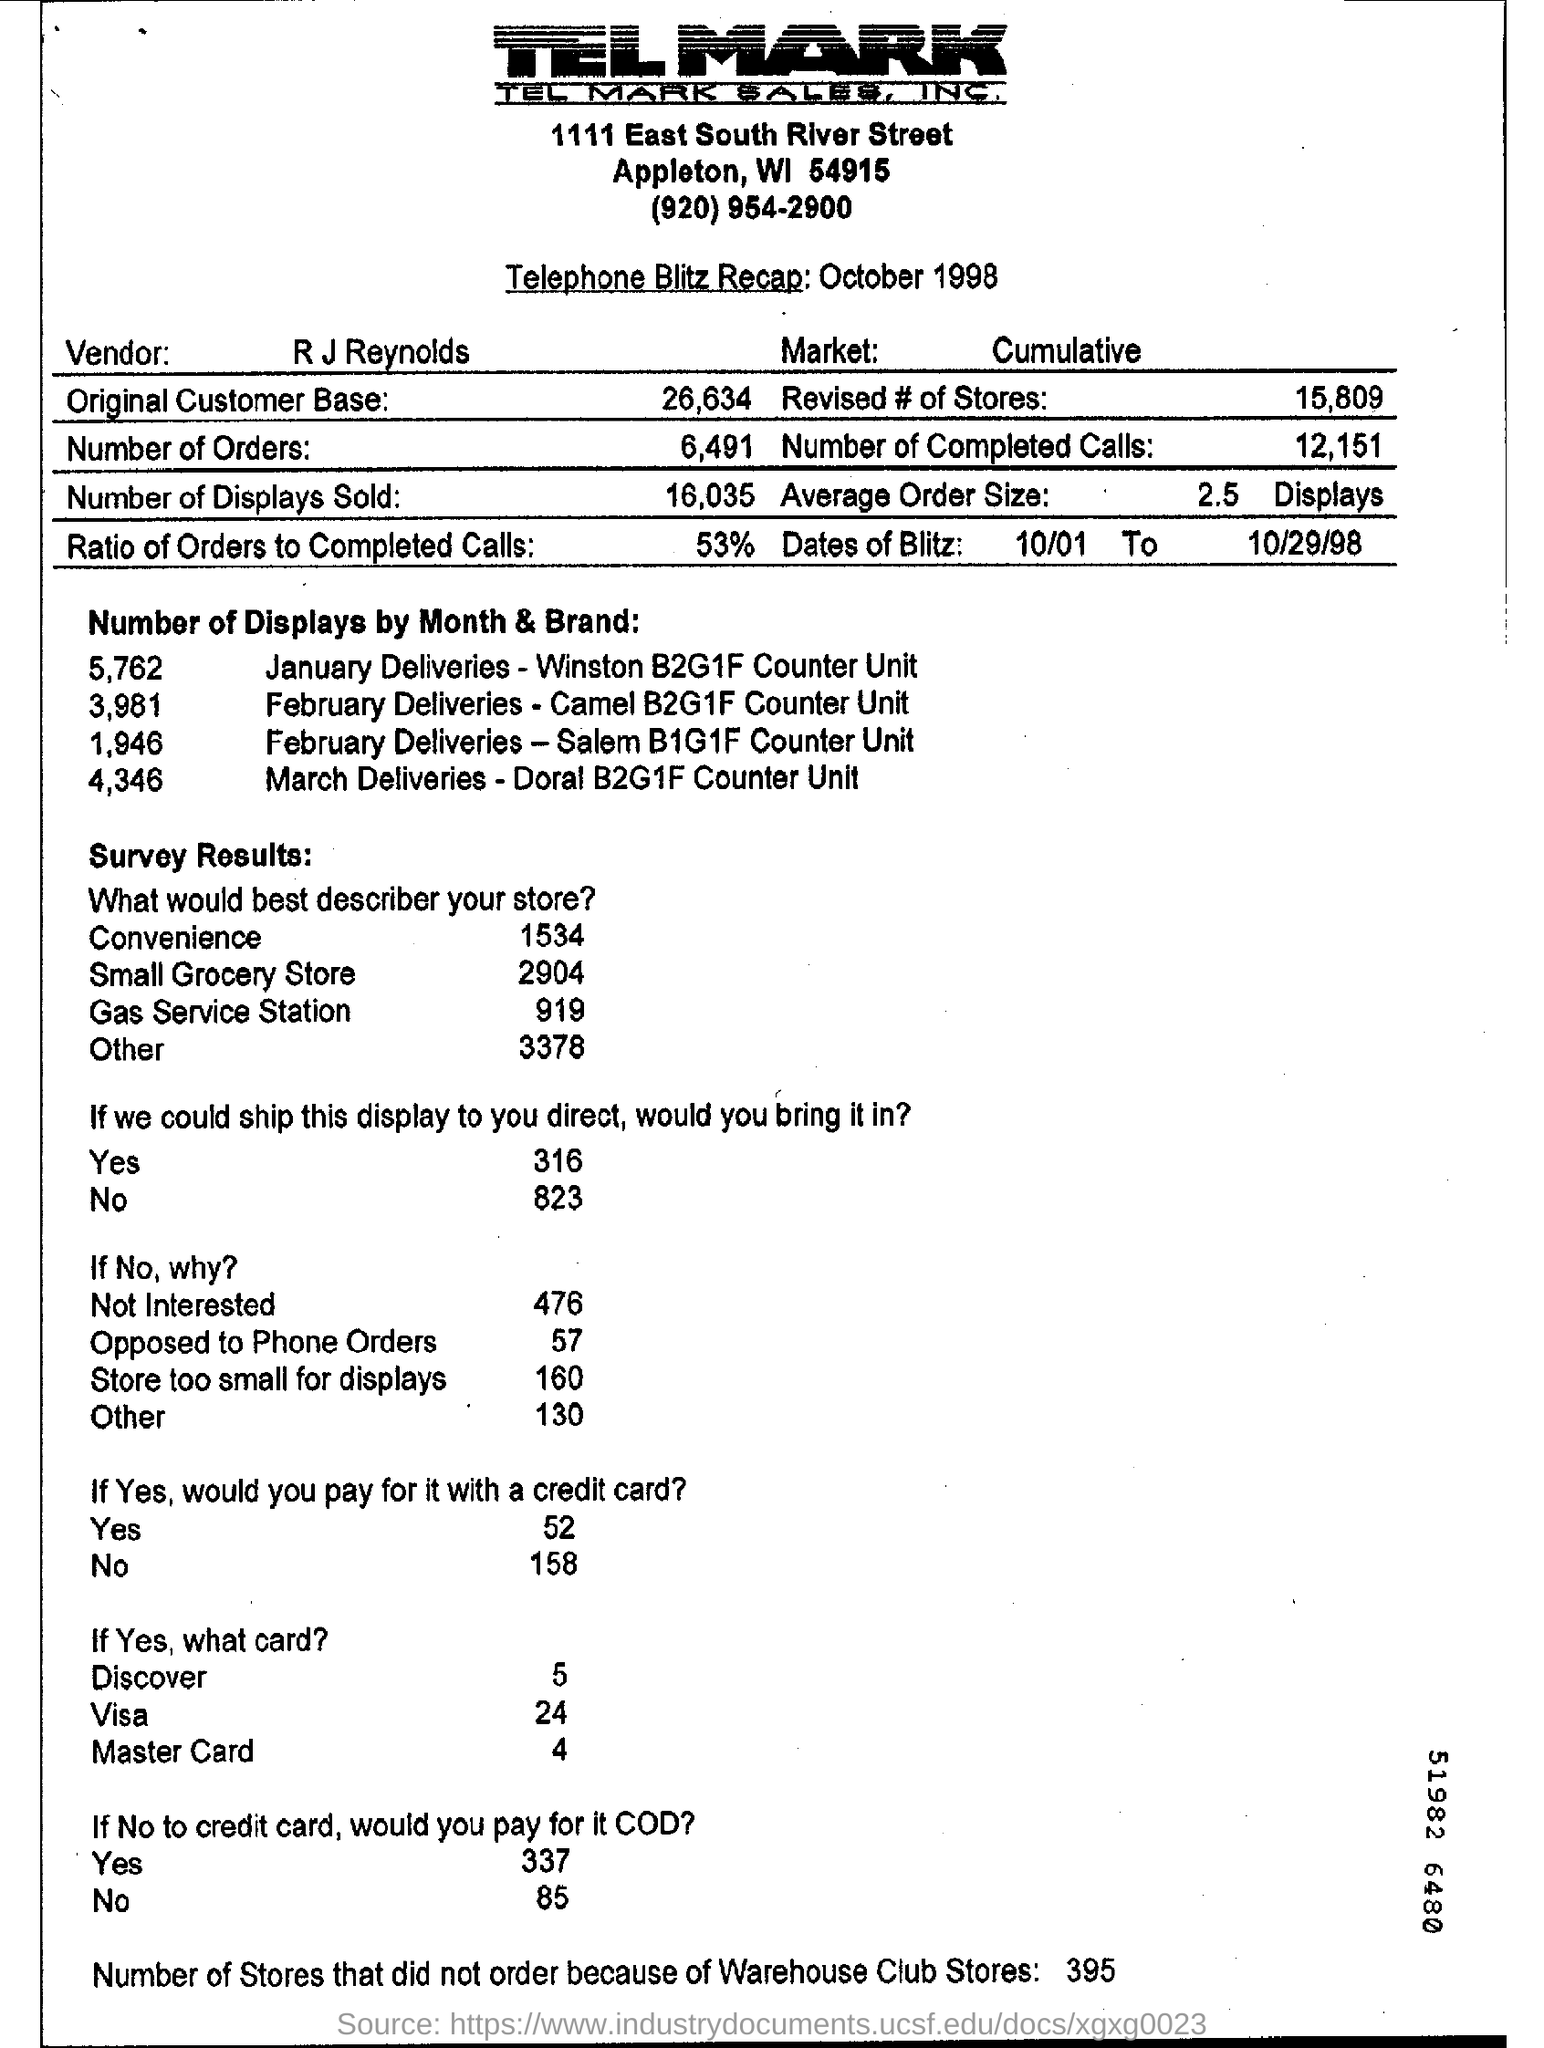Point out several critical features in this image. Approximately 16,035 displays were sold. 